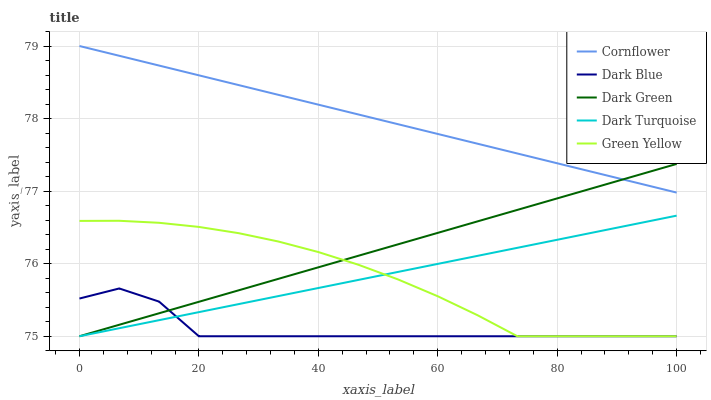Does Green Yellow have the minimum area under the curve?
Answer yes or no. No. Does Green Yellow have the maximum area under the curve?
Answer yes or no. No. Is Green Yellow the smoothest?
Answer yes or no. No. Is Green Yellow the roughest?
Answer yes or no. No. Does Green Yellow have the highest value?
Answer yes or no. No. Is Dark Blue less than Cornflower?
Answer yes or no. Yes. Is Cornflower greater than Dark Blue?
Answer yes or no. Yes. Does Dark Blue intersect Cornflower?
Answer yes or no. No. 